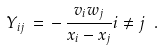Convert formula to latex. <formula><loc_0><loc_0><loc_500><loc_500>Y _ { i j } \, = \, - \, \frac { v _ { i } w _ { j } } { x _ { i } - x _ { j } } i \neq j \ .</formula> 